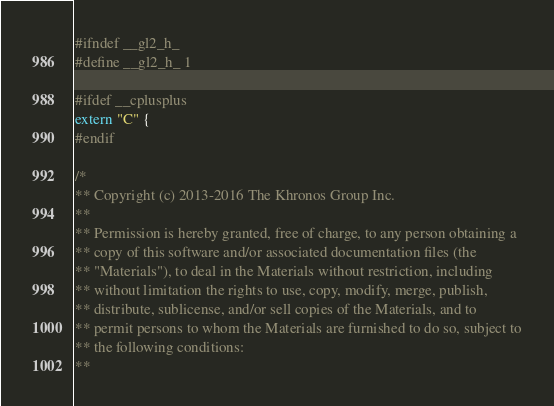Convert code to text. <code><loc_0><loc_0><loc_500><loc_500><_C_>#ifndef __gl2_h_
#define __gl2_h_ 1

#ifdef __cplusplus
extern "C" {
#endif

/*
** Copyright (c) 2013-2016 The Khronos Group Inc.
**
** Permission is hereby granted, free of charge, to any person obtaining a
** copy of this software and/or associated documentation files (the
** "Materials"), to deal in the Materials without restriction, including
** without limitation the rights to use, copy, modify, merge, publish,
** distribute, sublicense, and/or sell copies of the Materials, and to
** permit persons to whom the Materials are furnished to do so, subject to
** the following conditions:
**</code> 